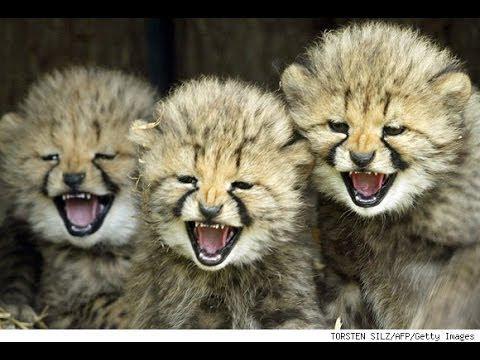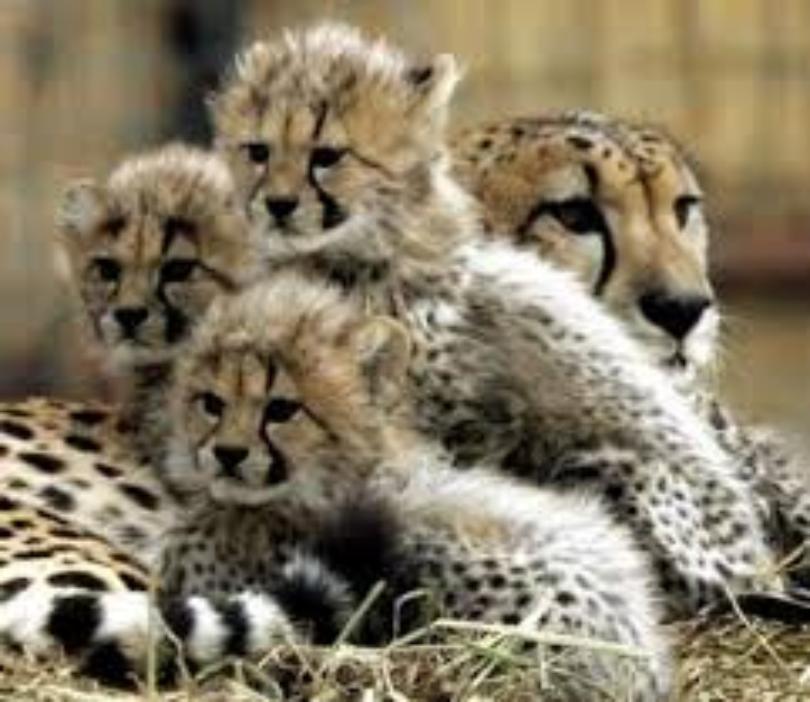The first image is the image on the left, the second image is the image on the right. Considering the images on both sides, is "The left image contains exactly three cheetahs." valid? Answer yes or no. Yes. The first image is the image on the left, the second image is the image on the right. Examine the images to the left and right. Is the description "At least three cubs and one adult leopard are visible." accurate? Answer yes or no. Yes. 